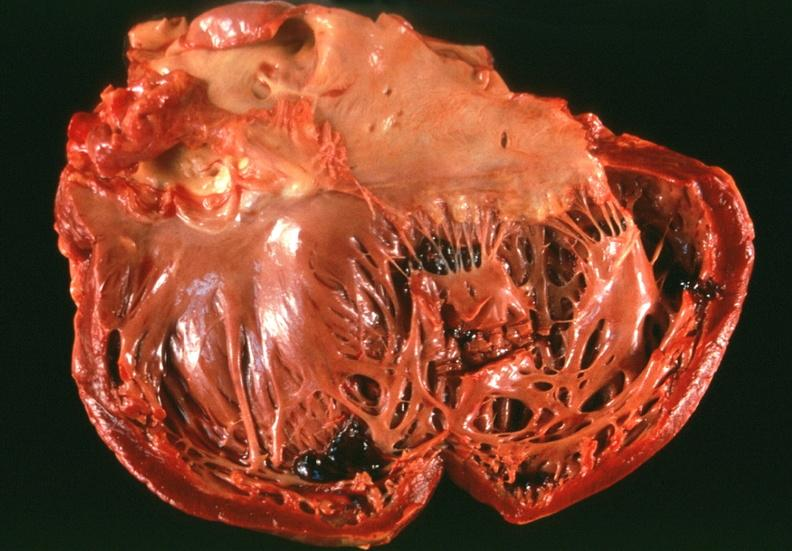what is congestive heart failure , left?
Answer the question using a single word or phrase. Ventricular dilatation 